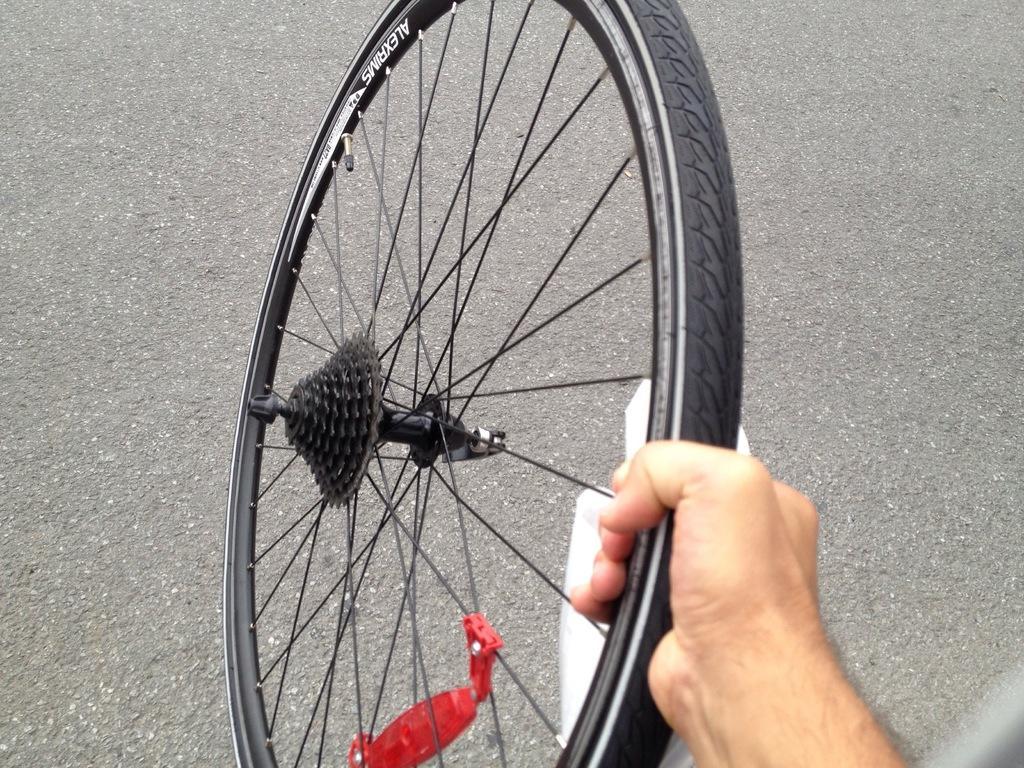Could you give a brief overview of what you see in this image? In the foreground of this image, there is a hand of a person holding a tyre. In the background, there is the road. 